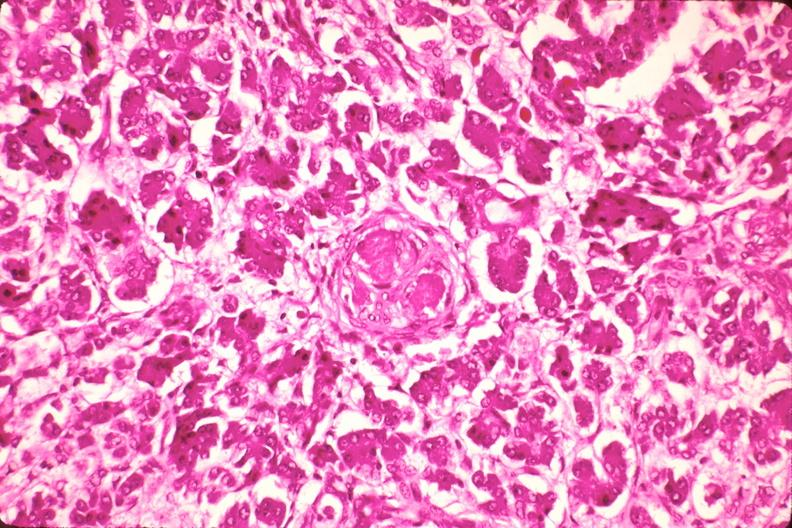where is this part in the figure?
Answer the question using a single word or phrase. Endocrine system 